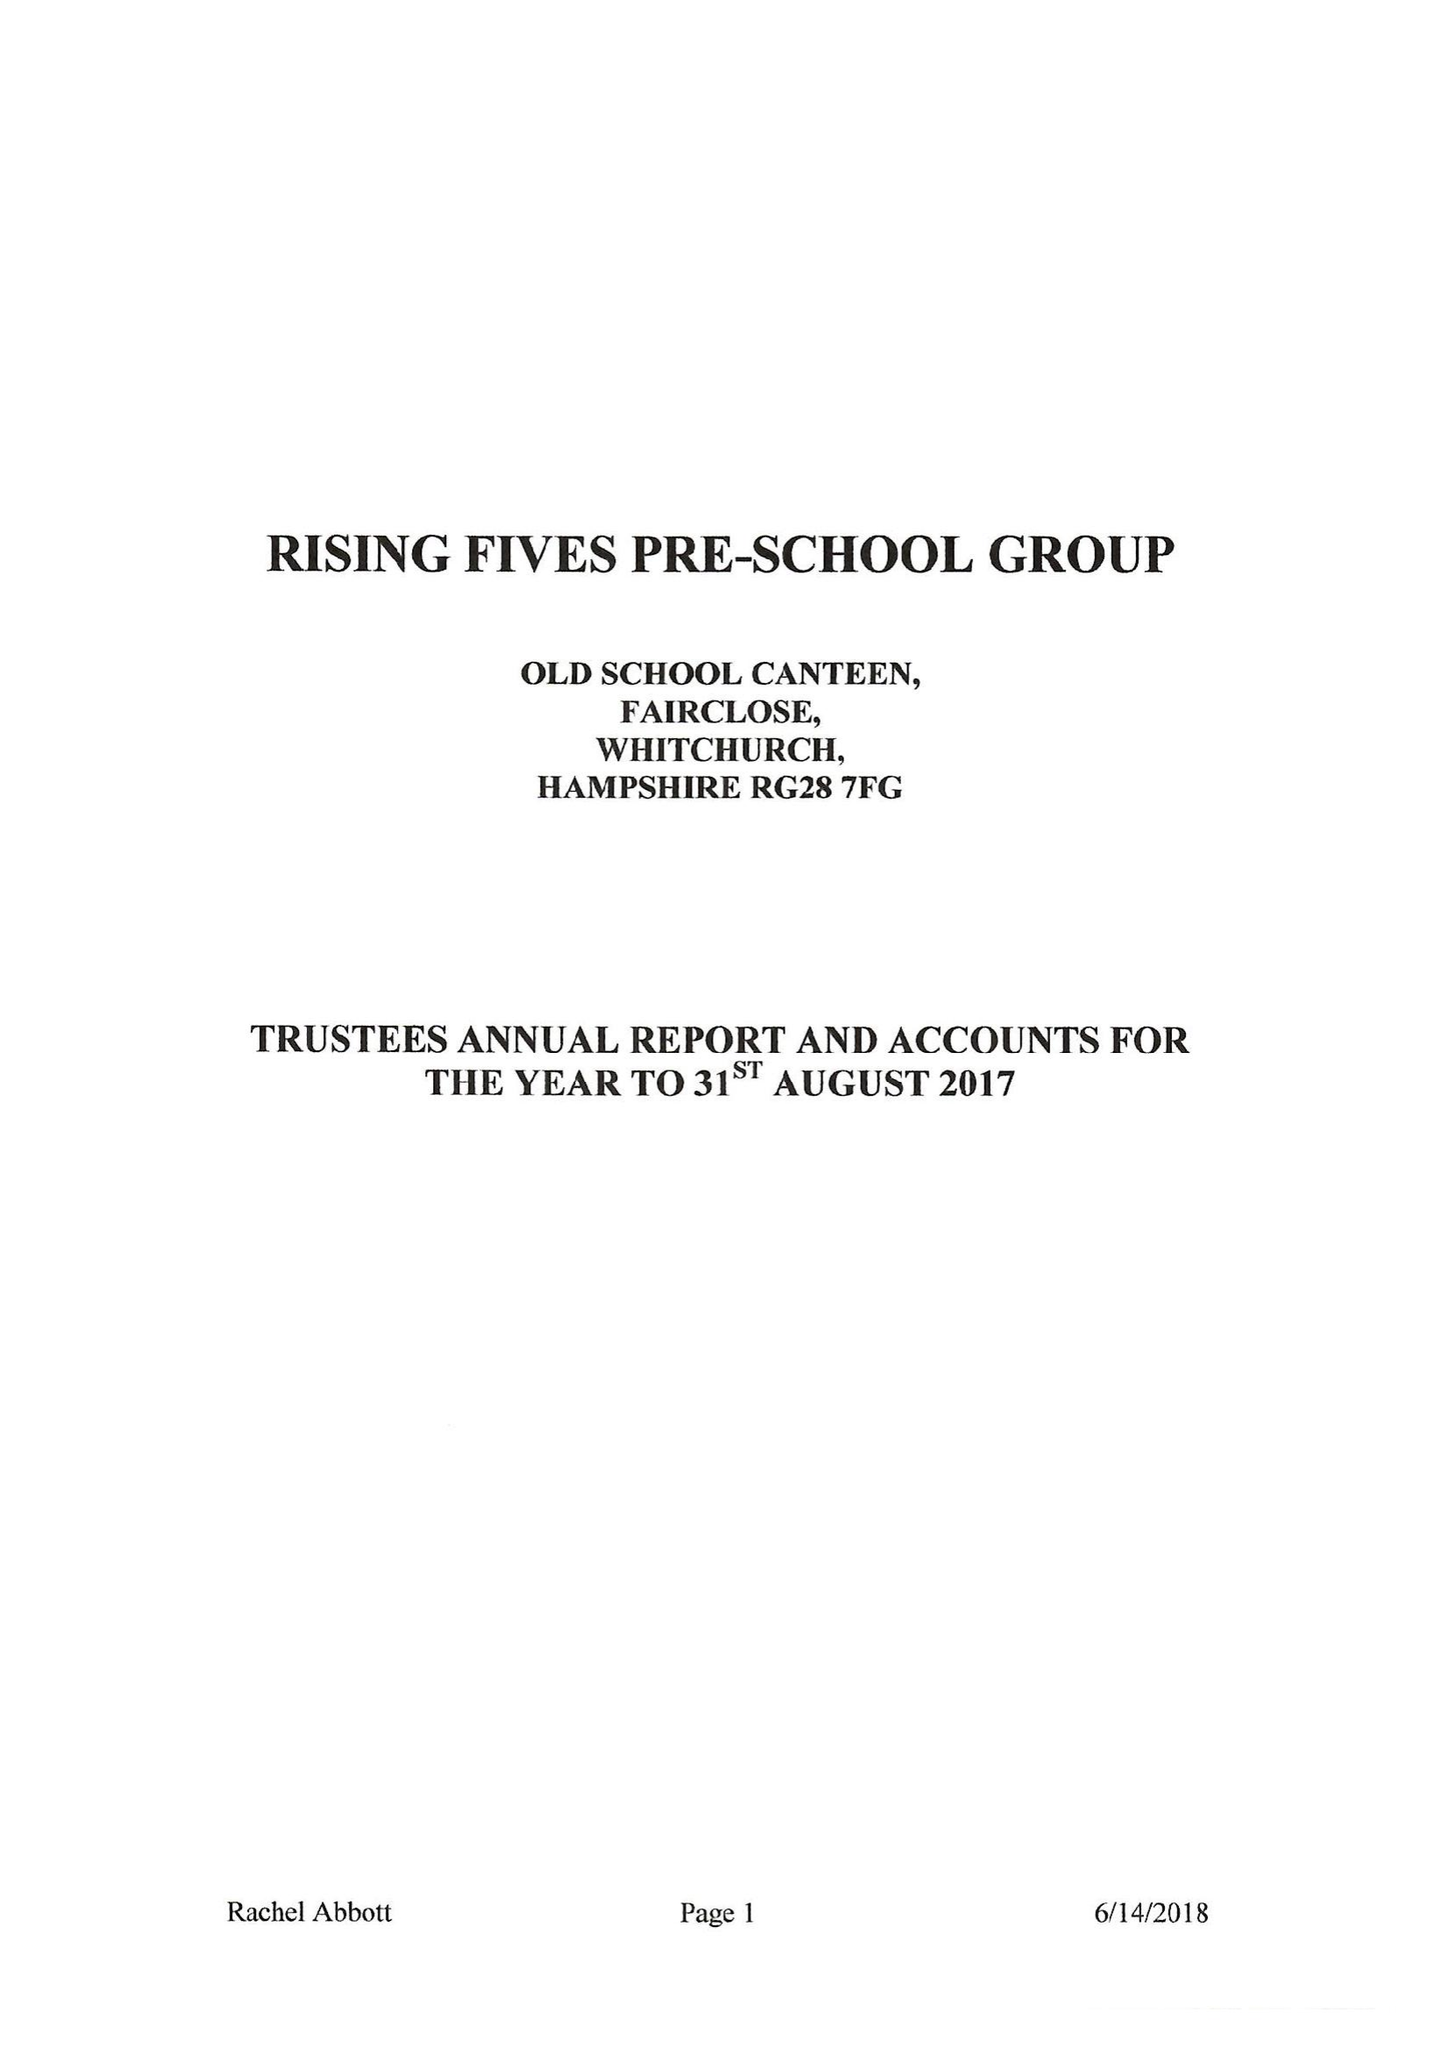What is the value for the address__post_town?
Answer the question using a single word or phrase. WHITCHURCH 